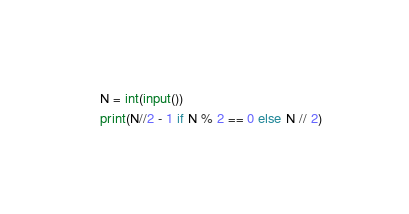<code> <loc_0><loc_0><loc_500><loc_500><_Python_>N = int(input())
print(N//2 - 1 if N % 2 == 0 else N // 2)</code> 